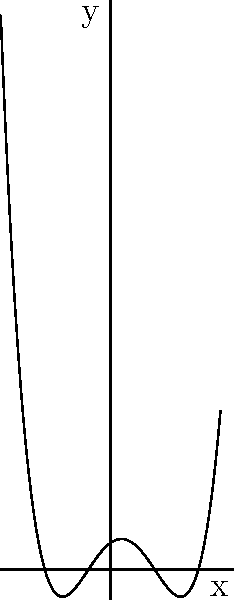As a motivational speaker who has overcome mental health struggles, you often use visual analogies to inspire athletes. Consider the graph of a polynomial function shown above, which represents the ups and downs of an athlete's journey. Based on this graph, what is the degree of the polynomial? To determine the degree of a polynomial based on its graph, we need to follow these steps:

1. Count the number of x-intercepts (roots) visible on the graph:
   We can see 4 x-intercepts where the graph crosses the x-axis.

2. Count the number of turning points (local maxima and minima):
   There are 3 turning points visible on the graph.

3. Compare these numbers:
   - The maximum number of x-intercepts for a polynomial of degree n is n.
   - The maximum number of turning points for a polynomial of degree n is n-1.

4. Choose the larger of:
   - The number of x-intercepts
   - The number of turning points plus 1

In this case:
- Number of x-intercepts: 4
- Number of turning points + 1: 3 + 1 = 4

Both methods suggest a degree of 4.

5. Verify the end behavior:
   The graph goes to positive infinity on both ends, which is consistent with an even-degree polynomial with a positive leading coefficient.

Therefore, the degree of the polynomial is 4.
Answer: 4 